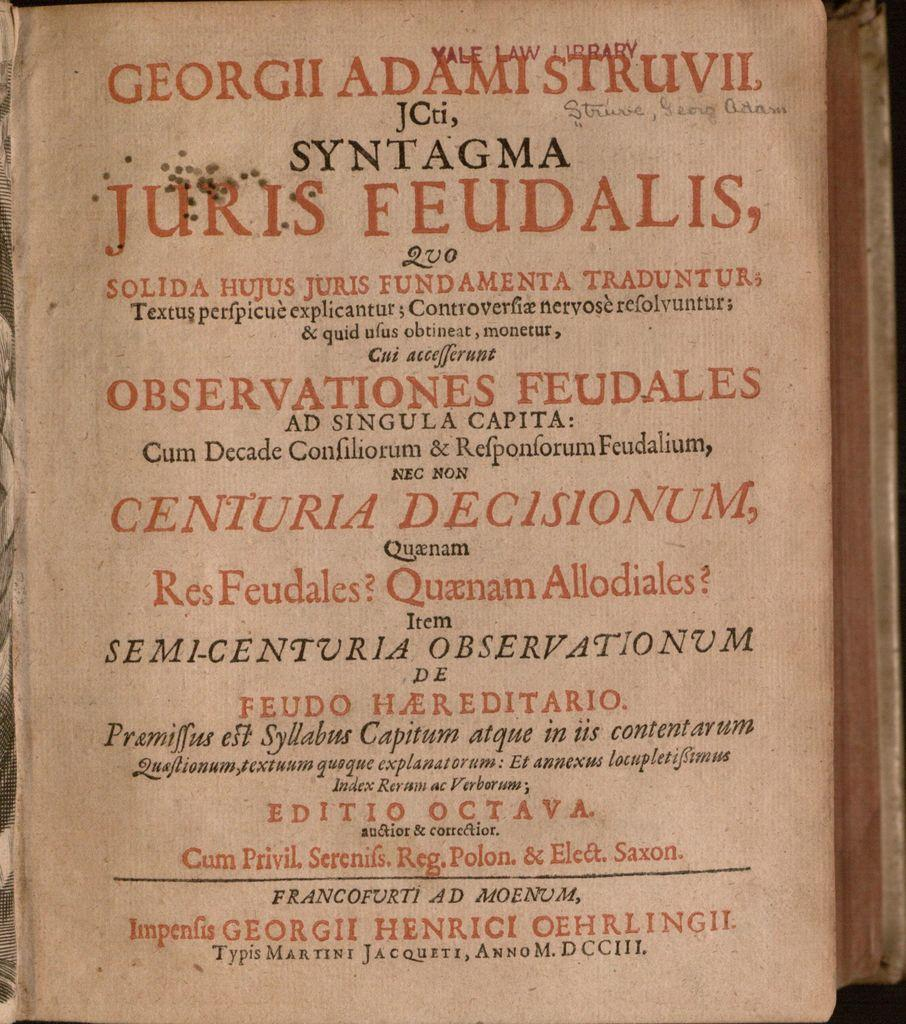<image>
Share a concise interpretation of the image provided. A page is stamped Yale Law Library in red near the top. 